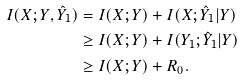Convert formula to latex. <formula><loc_0><loc_0><loc_500><loc_500>I ( X ; Y , \hat { Y } _ { 1 } ) & = I ( X ; Y ) + I ( X ; \hat { Y } _ { 1 } | Y ) \\ & \geq I ( X ; Y ) + I ( Y _ { 1 } ; \hat { Y } _ { 1 } | Y ) \\ & \geq I ( X ; Y ) + R _ { 0 } .</formula> 